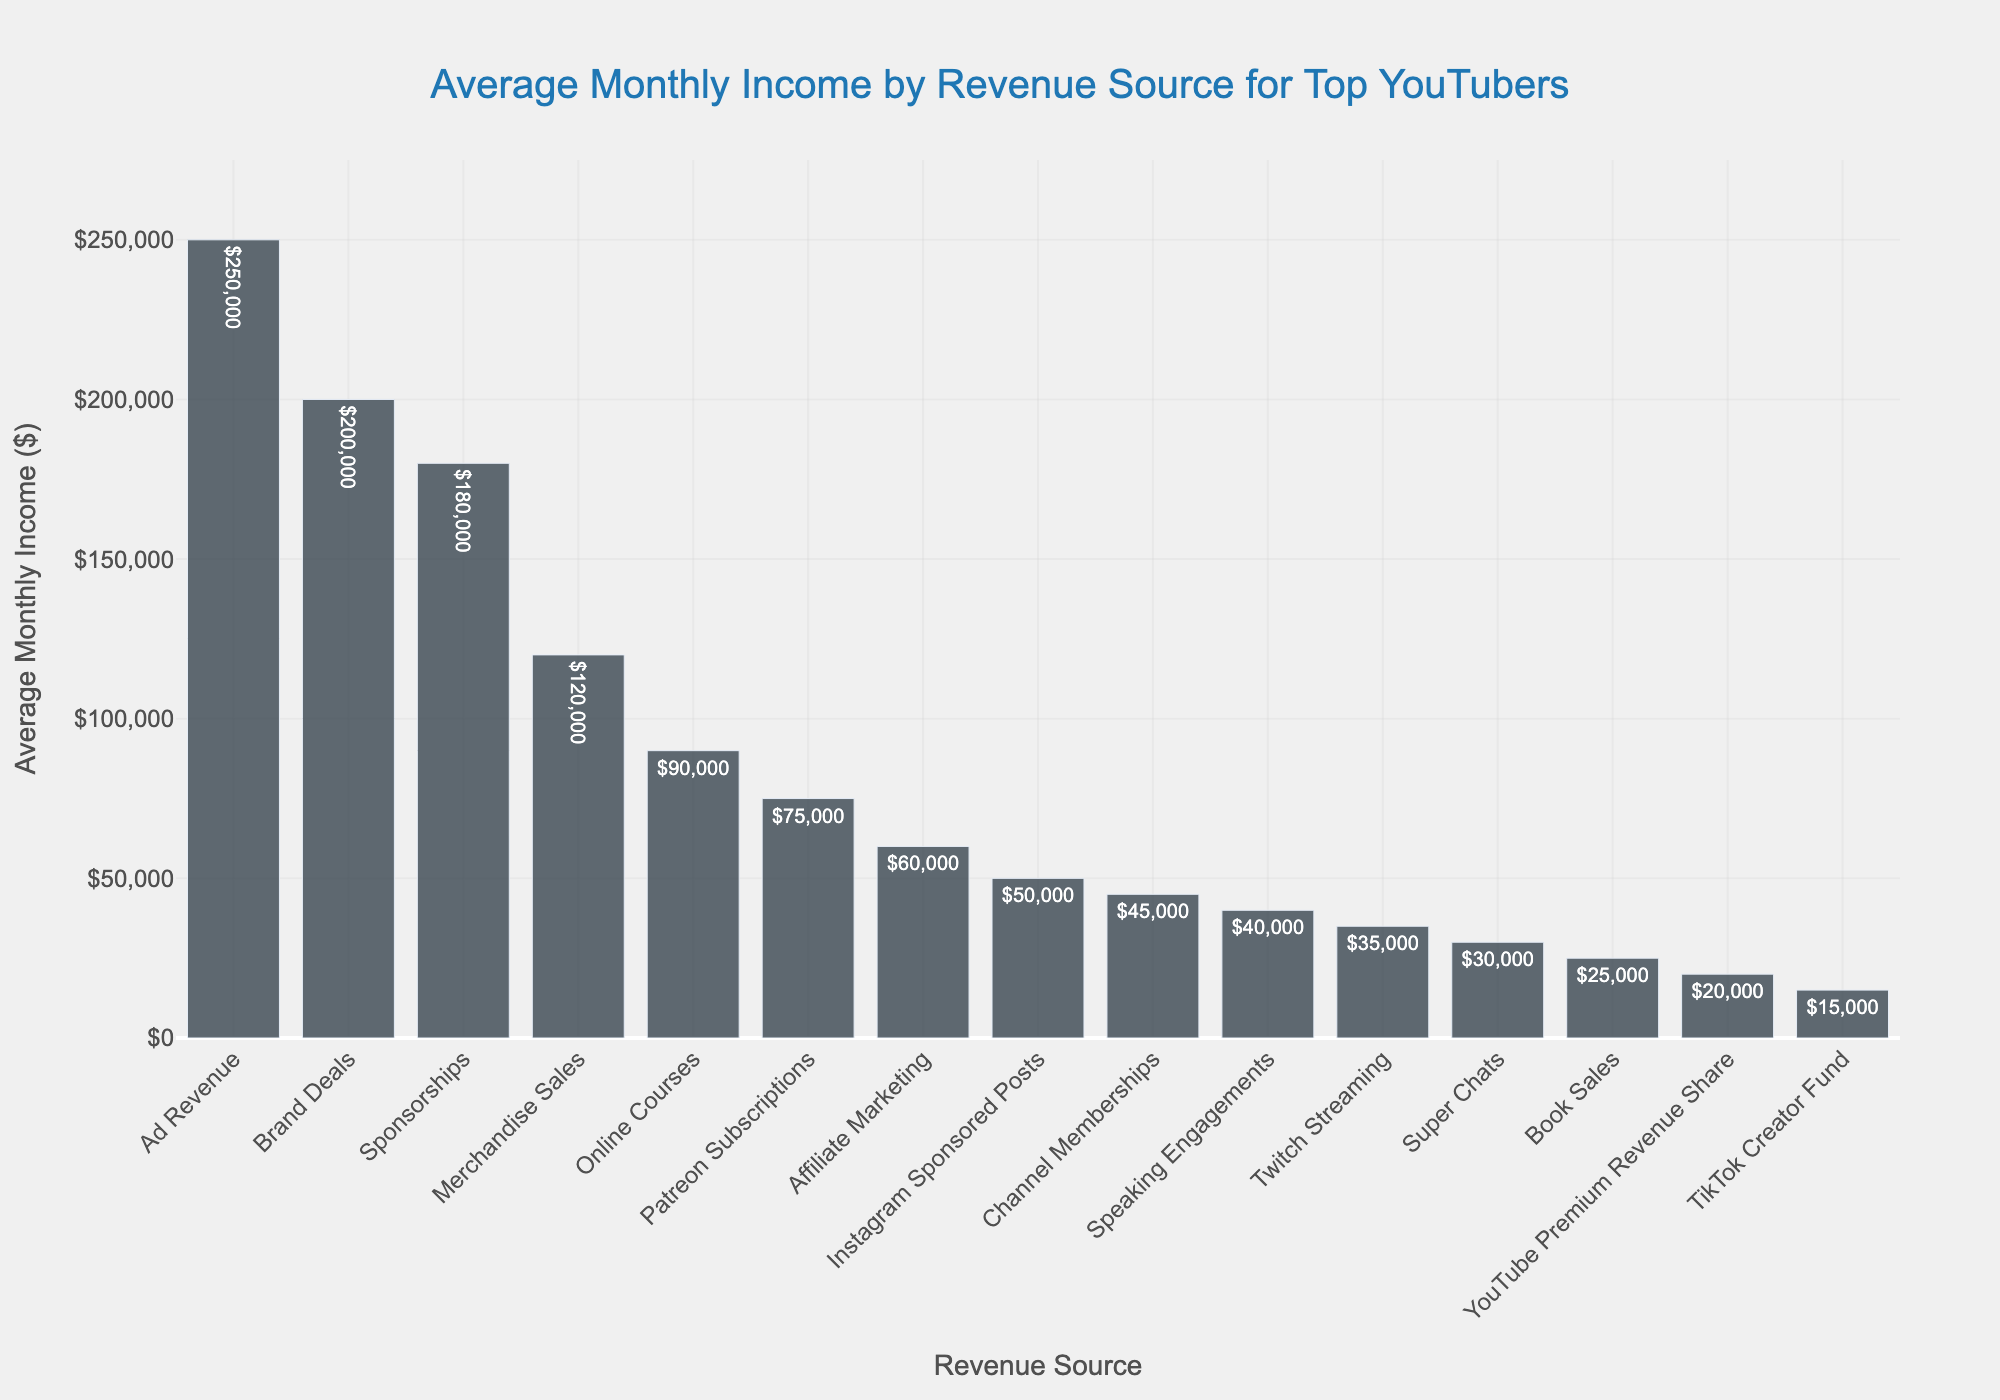Which revenue source generates the highest average monthly income? The bar chart shows the highest bar representing the revenue source that generates the most average monthly income.
Answer: Ad Revenue Which revenue source generates more monthly income: Sponsorships or Brand Deals? By comparing the heights of the bars for Sponsorships and Brand Deals, we can see that the bar for Sponsorships is higher.
Answer: Sponsorships How much more on average do YouTubers earn from Ad Revenue compared to Merchandise Sales per month? Locate the bars for Ad Revenue and Merchandise Sales. Note their values ($250,000 and $120,000, respectively), then subtract the Merchandise Sales from Ad Revenue ($250,000 - $120,000 = $130,000).
Answer: $130,000 What is the combined average monthly income from Affiliate Marketing, Speaking Engagements, and Online Courses? Identify the bars for Affiliate Marketing ($60,000), Speaking Engagements ($40,000), and Online Courses ($90,000), then sum their values ($60,000 + $40,000 + $90,000 = $190,000).
Answer: $190,000 Between Super Chats and Channel Memberships, which revenue source generates less, and by how much? Look at the bars for Super Chats ($30,000) and Channel Memberships ($45,000). Calculate the difference ($45,000 - $30,000 = $15,000). Super Chats generate less.
Answer: Super Chats, $15,000 What percentage of the total average monthly income from YouTube Premium Revenue Share ($20,000) and Twitch Streaming ($35,000) is the Twitch Streaming income? First, find the total income from both sources ($20,000 + $35,000 = $55,000). Then, calculate the percentage of Twitch Streaming ($35,000 / $55,000 * 100 ≈ 63.64%).
Answer: ≈ 63.64% Which revenue source is exactly three times the average monthly income from Book Sales? Identify the value for Book Sales ($25,000). Calculate three times this amount ($25,000 * 3 = $75,000). Find the matching bar at $75,000, which corresponds to Patreon Subscriptions.
Answer: Patreon Subscriptions What is the median average monthly income of all the revenue sources in the chart? List all the average monthly incomes in ascending order. The median is the middle value of the sorted list, which involves finding the 8th value in this dataset of 15 entries. After sorting, the 8th value is Channel Memberships at $45,000.
Answer: $45,000 How much more do YouTubers earn from Brand Deals compared to Online Courses? Locate the bars for Brand Deals ($200,000) and Online Courses ($90,000). Subtract the value of Online Courses from Brand Deals ($200,000 - $90,000 = $110,000).
Answer: $110,000 What is the ratio of the income from Instagram Sponsored Posts to TikTok Creator Fund? Identify the values for Instagram Sponsored Posts ($50,000) and TikTok Creator Fund ($15,000), then divide the Instagram income by the TikTok income ($50,000 / $15,000 ≈ 3.33).
Answer: ≈ 3.33 